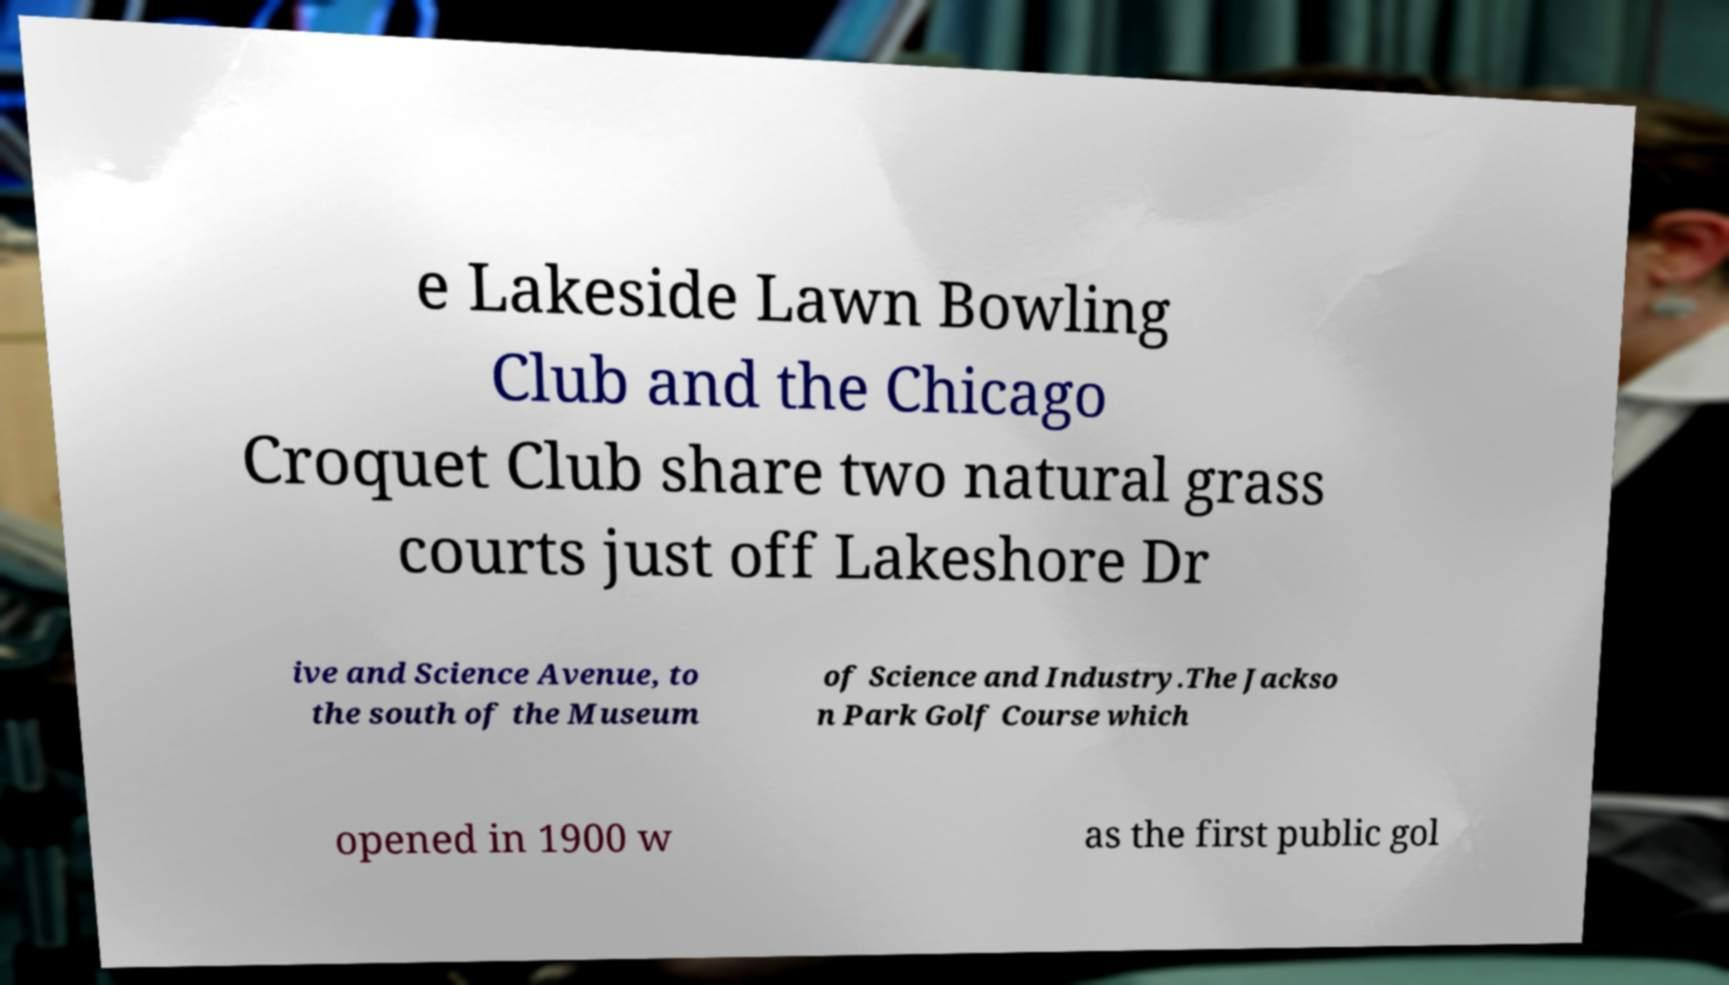Could you assist in decoding the text presented in this image and type it out clearly? e Lakeside Lawn Bowling Club and the Chicago Croquet Club share two natural grass courts just off Lakeshore Dr ive and Science Avenue, to the south of the Museum of Science and Industry.The Jackso n Park Golf Course which opened in 1900 w as the first public gol 